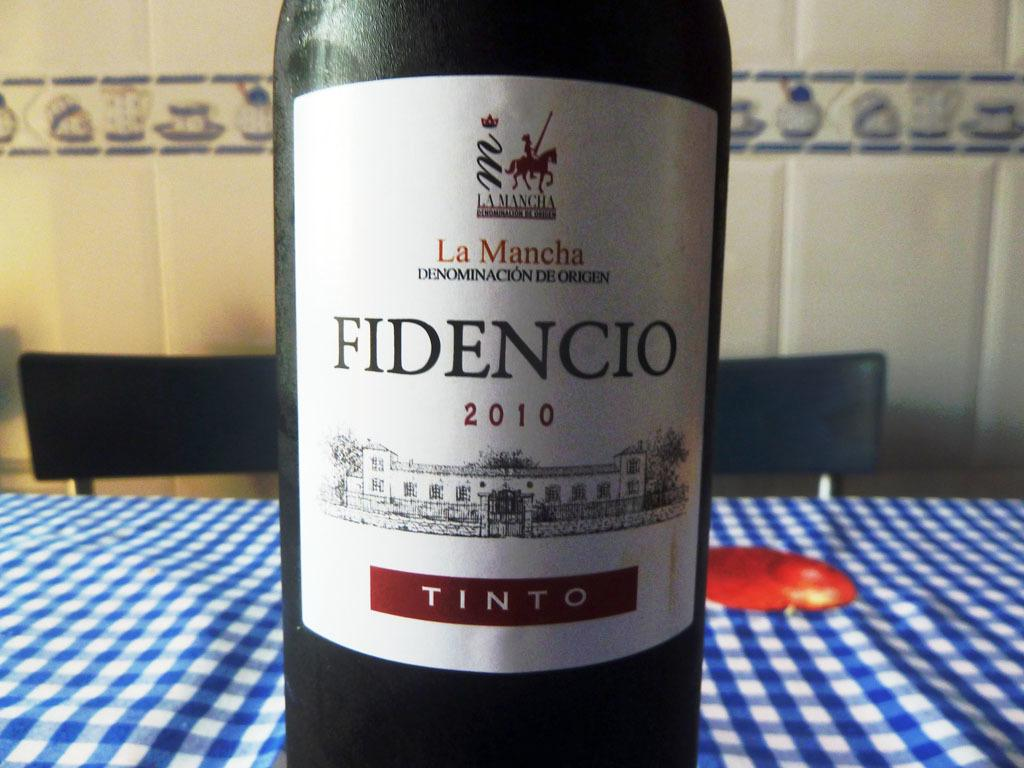<image>
Summarize the visual content of the image. A bottle of Fidencio wine is on the table. 